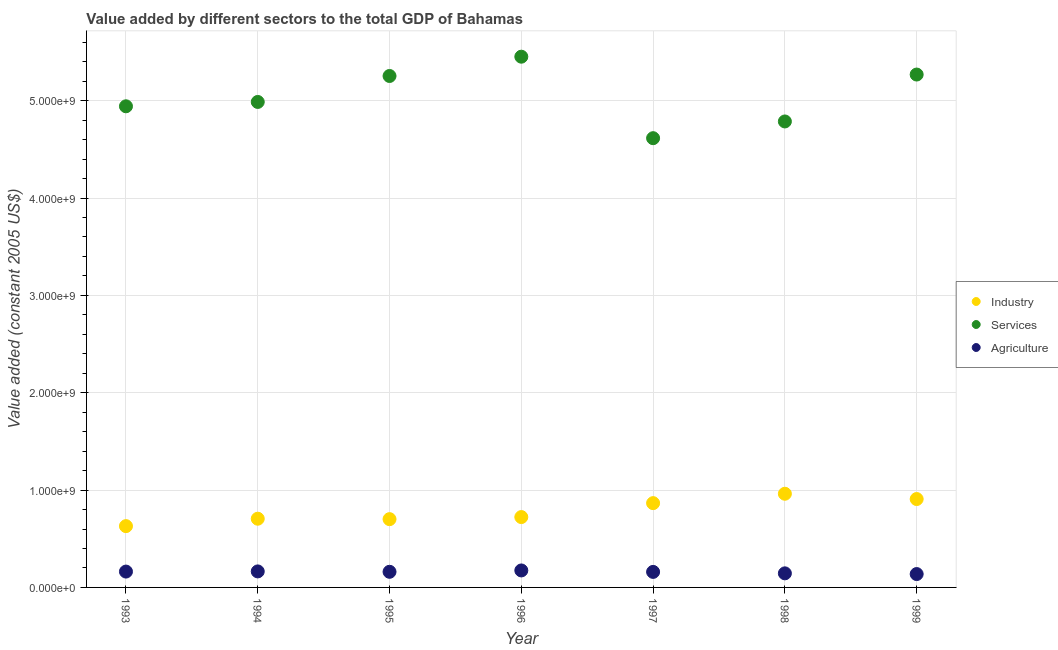Is the number of dotlines equal to the number of legend labels?
Give a very brief answer. Yes. What is the value added by agricultural sector in 1997?
Your answer should be very brief. 1.59e+08. Across all years, what is the maximum value added by agricultural sector?
Your answer should be very brief. 1.74e+08. Across all years, what is the minimum value added by industrial sector?
Offer a very short reply. 6.30e+08. In which year was the value added by services minimum?
Provide a succinct answer. 1997. What is the total value added by industrial sector in the graph?
Your answer should be very brief. 5.50e+09. What is the difference between the value added by services in 1994 and that in 1999?
Offer a terse response. -2.81e+08. What is the difference between the value added by services in 1997 and the value added by agricultural sector in 1995?
Your answer should be compact. 4.45e+09. What is the average value added by industrial sector per year?
Offer a very short reply. 7.85e+08. In the year 1993, what is the difference between the value added by industrial sector and value added by services?
Ensure brevity in your answer.  -4.31e+09. What is the ratio of the value added by industrial sector in 1997 to that in 1999?
Offer a very short reply. 0.95. Is the value added by agricultural sector in 1993 less than that in 1997?
Provide a short and direct response. No. Is the difference between the value added by industrial sector in 1996 and 1997 greater than the difference between the value added by services in 1996 and 1997?
Make the answer very short. No. What is the difference between the highest and the second highest value added by agricultural sector?
Make the answer very short. 9.92e+06. What is the difference between the highest and the lowest value added by industrial sector?
Keep it short and to the point. 3.32e+08. In how many years, is the value added by industrial sector greater than the average value added by industrial sector taken over all years?
Your answer should be compact. 3. Is it the case that in every year, the sum of the value added by industrial sector and value added by services is greater than the value added by agricultural sector?
Provide a succinct answer. Yes. Does the value added by services monotonically increase over the years?
Make the answer very short. No. How many dotlines are there?
Your answer should be very brief. 3. Does the graph contain any zero values?
Keep it short and to the point. No. Where does the legend appear in the graph?
Provide a short and direct response. Center right. What is the title of the graph?
Keep it short and to the point. Value added by different sectors to the total GDP of Bahamas. Does "Ages 15-64" appear as one of the legend labels in the graph?
Your response must be concise. No. What is the label or title of the Y-axis?
Offer a very short reply. Value added (constant 2005 US$). What is the Value added (constant 2005 US$) in Industry in 1993?
Your answer should be compact. 6.30e+08. What is the Value added (constant 2005 US$) in Services in 1993?
Give a very brief answer. 4.94e+09. What is the Value added (constant 2005 US$) in Agriculture in 1993?
Provide a short and direct response. 1.63e+08. What is the Value added (constant 2005 US$) of Industry in 1994?
Provide a succinct answer. 7.06e+08. What is the Value added (constant 2005 US$) in Services in 1994?
Your answer should be compact. 4.99e+09. What is the Value added (constant 2005 US$) in Agriculture in 1994?
Give a very brief answer. 1.65e+08. What is the Value added (constant 2005 US$) in Industry in 1995?
Offer a terse response. 7.01e+08. What is the Value added (constant 2005 US$) in Services in 1995?
Provide a succinct answer. 5.25e+09. What is the Value added (constant 2005 US$) in Agriculture in 1995?
Give a very brief answer. 1.61e+08. What is the Value added (constant 2005 US$) in Industry in 1996?
Offer a very short reply. 7.23e+08. What is the Value added (constant 2005 US$) in Services in 1996?
Offer a very short reply. 5.45e+09. What is the Value added (constant 2005 US$) in Agriculture in 1996?
Your answer should be compact. 1.74e+08. What is the Value added (constant 2005 US$) of Industry in 1997?
Provide a succinct answer. 8.66e+08. What is the Value added (constant 2005 US$) in Services in 1997?
Make the answer very short. 4.61e+09. What is the Value added (constant 2005 US$) of Agriculture in 1997?
Offer a terse response. 1.59e+08. What is the Value added (constant 2005 US$) in Industry in 1998?
Offer a terse response. 9.62e+08. What is the Value added (constant 2005 US$) of Services in 1998?
Provide a succinct answer. 4.79e+09. What is the Value added (constant 2005 US$) of Agriculture in 1998?
Provide a succinct answer. 1.45e+08. What is the Value added (constant 2005 US$) of Industry in 1999?
Your answer should be very brief. 9.08e+08. What is the Value added (constant 2005 US$) of Services in 1999?
Your response must be concise. 5.27e+09. What is the Value added (constant 2005 US$) in Agriculture in 1999?
Provide a short and direct response. 1.37e+08. Across all years, what is the maximum Value added (constant 2005 US$) in Industry?
Offer a very short reply. 9.62e+08. Across all years, what is the maximum Value added (constant 2005 US$) of Services?
Offer a terse response. 5.45e+09. Across all years, what is the maximum Value added (constant 2005 US$) of Agriculture?
Keep it short and to the point. 1.74e+08. Across all years, what is the minimum Value added (constant 2005 US$) of Industry?
Provide a succinct answer. 6.30e+08. Across all years, what is the minimum Value added (constant 2005 US$) of Services?
Your answer should be compact. 4.61e+09. Across all years, what is the minimum Value added (constant 2005 US$) of Agriculture?
Make the answer very short. 1.37e+08. What is the total Value added (constant 2005 US$) of Industry in the graph?
Give a very brief answer. 5.50e+09. What is the total Value added (constant 2005 US$) in Services in the graph?
Your answer should be very brief. 3.53e+1. What is the total Value added (constant 2005 US$) of Agriculture in the graph?
Your response must be concise. 1.10e+09. What is the difference between the Value added (constant 2005 US$) in Industry in 1993 and that in 1994?
Make the answer very short. -7.61e+07. What is the difference between the Value added (constant 2005 US$) of Services in 1993 and that in 1994?
Provide a succinct answer. -4.47e+07. What is the difference between the Value added (constant 2005 US$) of Agriculture in 1993 and that in 1994?
Your response must be concise. -1.69e+06. What is the difference between the Value added (constant 2005 US$) of Industry in 1993 and that in 1995?
Make the answer very short. -7.16e+07. What is the difference between the Value added (constant 2005 US$) in Services in 1993 and that in 1995?
Keep it short and to the point. -3.11e+08. What is the difference between the Value added (constant 2005 US$) in Agriculture in 1993 and that in 1995?
Ensure brevity in your answer.  2.29e+06. What is the difference between the Value added (constant 2005 US$) in Industry in 1993 and that in 1996?
Give a very brief answer. -9.30e+07. What is the difference between the Value added (constant 2005 US$) in Services in 1993 and that in 1996?
Your answer should be compact. -5.10e+08. What is the difference between the Value added (constant 2005 US$) of Agriculture in 1993 and that in 1996?
Make the answer very short. -1.16e+07. What is the difference between the Value added (constant 2005 US$) of Industry in 1993 and that in 1997?
Give a very brief answer. -2.36e+08. What is the difference between the Value added (constant 2005 US$) in Services in 1993 and that in 1997?
Your answer should be compact. 3.28e+08. What is the difference between the Value added (constant 2005 US$) in Agriculture in 1993 and that in 1997?
Make the answer very short. 3.39e+06. What is the difference between the Value added (constant 2005 US$) of Industry in 1993 and that in 1998?
Make the answer very short. -3.32e+08. What is the difference between the Value added (constant 2005 US$) in Services in 1993 and that in 1998?
Ensure brevity in your answer.  1.56e+08. What is the difference between the Value added (constant 2005 US$) of Agriculture in 1993 and that in 1998?
Provide a short and direct response. 1.82e+07. What is the difference between the Value added (constant 2005 US$) of Industry in 1993 and that in 1999?
Your response must be concise. -2.78e+08. What is the difference between the Value added (constant 2005 US$) in Services in 1993 and that in 1999?
Your answer should be compact. -3.26e+08. What is the difference between the Value added (constant 2005 US$) of Agriculture in 1993 and that in 1999?
Provide a succinct answer. 2.55e+07. What is the difference between the Value added (constant 2005 US$) in Industry in 1994 and that in 1995?
Your answer should be very brief. 4.48e+06. What is the difference between the Value added (constant 2005 US$) in Services in 1994 and that in 1995?
Provide a succinct answer. -2.67e+08. What is the difference between the Value added (constant 2005 US$) of Agriculture in 1994 and that in 1995?
Provide a succinct answer. 3.98e+06. What is the difference between the Value added (constant 2005 US$) of Industry in 1994 and that in 1996?
Give a very brief answer. -1.69e+07. What is the difference between the Value added (constant 2005 US$) in Services in 1994 and that in 1996?
Offer a terse response. -4.65e+08. What is the difference between the Value added (constant 2005 US$) of Agriculture in 1994 and that in 1996?
Offer a very short reply. -9.92e+06. What is the difference between the Value added (constant 2005 US$) in Industry in 1994 and that in 1997?
Your answer should be compact. -1.60e+08. What is the difference between the Value added (constant 2005 US$) of Services in 1994 and that in 1997?
Give a very brief answer. 3.72e+08. What is the difference between the Value added (constant 2005 US$) of Agriculture in 1994 and that in 1997?
Your response must be concise. 5.08e+06. What is the difference between the Value added (constant 2005 US$) of Industry in 1994 and that in 1998?
Ensure brevity in your answer.  -2.56e+08. What is the difference between the Value added (constant 2005 US$) of Services in 1994 and that in 1998?
Ensure brevity in your answer.  2.00e+08. What is the difference between the Value added (constant 2005 US$) in Agriculture in 1994 and that in 1998?
Offer a very short reply. 1.99e+07. What is the difference between the Value added (constant 2005 US$) of Industry in 1994 and that in 1999?
Offer a very short reply. -2.02e+08. What is the difference between the Value added (constant 2005 US$) of Services in 1994 and that in 1999?
Your answer should be compact. -2.81e+08. What is the difference between the Value added (constant 2005 US$) in Agriculture in 1994 and that in 1999?
Provide a short and direct response. 2.72e+07. What is the difference between the Value added (constant 2005 US$) of Industry in 1995 and that in 1996?
Provide a succinct answer. -2.14e+07. What is the difference between the Value added (constant 2005 US$) in Services in 1995 and that in 1996?
Offer a very short reply. -1.98e+08. What is the difference between the Value added (constant 2005 US$) in Agriculture in 1995 and that in 1996?
Your response must be concise. -1.39e+07. What is the difference between the Value added (constant 2005 US$) in Industry in 1995 and that in 1997?
Your response must be concise. -1.64e+08. What is the difference between the Value added (constant 2005 US$) in Services in 1995 and that in 1997?
Ensure brevity in your answer.  6.39e+08. What is the difference between the Value added (constant 2005 US$) of Agriculture in 1995 and that in 1997?
Your response must be concise. 1.10e+06. What is the difference between the Value added (constant 2005 US$) in Industry in 1995 and that in 1998?
Offer a very short reply. -2.61e+08. What is the difference between the Value added (constant 2005 US$) of Services in 1995 and that in 1998?
Offer a terse response. 4.67e+08. What is the difference between the Value added (constant 2005 US$) of Agriculture in 1995 and that in 1998?
Give a very brief answer. 1.59e+07. What is the difference between the Value added (constant 2005 US$) of Industry in 1995 and that in 1999?
Provide a succinct answer. -2.07e+08. What is the difference between the Value added (constant 2005 US$) of Services in 1995 and that in 1999?
Your response must be concise. -1.48e+07. What is the difference between the Value added (constant 2005 US$) of Agriculture in 1995 and that in 1999?
Provide a short and direct response. 2.32e+07. What is the difference between the Value added (constant 2005 US$) of Industry in 1996 and that in 1997?
Offer a terse response. -1.43e+08. What is the difference between the Value added (constant 2005 US$) in Services in 1996 and that in 1997?
Ensure brevity in your answer.  8.37e+08. What is the difference between the Value added (constant 2005 US$) of Agriculture in 1996 and that in 1997?
Keep it short and to the point. 1.50e+07. What is the difference between the Value added (constant 2005 US$) in Industry in 1996 and that in 1998?
Your response must be concise. -2.39e+08. What is the difference between the Value added (constant 2005 US$) of Services in 1996 and that in 1998?
Provide a short and direct response. 6.65e+08. What is the difference between the Value added (constant 2005 US$) of Agriculture in 1996 and that in 1998?
Make the answer very short. 2.98e+07. What is the difference between the Value added (constant 2005 US$) of Industry in 1996 and that in 1999?
Make the answer very short. -1.85e+08. What is the difference between the Value added (constant 2005 US$) in Services in 1996 and that in 1999?
Provide a succinct answer. 1.83e+08. What is the difference between the Value added (constant 2005 US$) of Agriculture in 1996 and that in 1999?
Offer a terse response. 3.71e+07. What is the difference between the Value added (constant 2005 US$) of Industry in 1997 and that in 1998?
Your response must be concise. -9.64e+07. What is the difference between the Value added (constant 2005 US$) of Services in 1997 and that in 1998?
Keep it short and to the point. -1.72e+08. What is the difference between the Value added (constant 2005 US$) in Agriculture in 1997 and that in 1998?
Offer a very short reply. 1.48e+07. What is the difference between the Value added (constant 2005 US$) in Industry in 1997 and that in 1999?
Make the answer very short. -4.21e+07. What is the difference between the Value added (constant 2005 US$) of Services in 1997 and that in 1999?
Keep it short and to the point. -6.54e+08. What is the difference between the Value added (constant 2005 US$) of Agriculture in 1997 and that in 1999?
Your answer should be very brief. 2.21e+07. What is the difference between the Value added (constant 2005 US$) in Industry in 1998 and that in 1999?
Offer a very short reply. 5.42e+07. What is the difference between the Value added (constant 2005 US$) of Services in 1998 and that in 1999?
Offer a terse response. -4.82e+08. What is the difference between the Value added (constant 2005 US$) of Agriculture in 1998 and that in 1999?
Your response must be concise. 7.27e+06. What is the difference between the Value added (constant 2005 US$) of Industry in 1993 and the Value added (constant 2005 US$) of Services in 1994?
Offer a very short reply. -4.36e+09. What is the difference between the Value added (constant 2005 US$) in Industry in 1993 and the Value added (constant 2005 US$) in Agriculture in 1994?
Provide a succinct answer. 4.65e+08. What is the difference between the Value added (constant 2005 US$) in Services in 1993 and the Value added (constant 2005 US$) in Agriculture in 1994?
Your answer should be compact. 4.78e+09. What is the difference between the Value added (constant 2005 US$) in Industry in 1993 and the Value added (constant 2005 US$) in Services in 1995?
Your answer should be compact. -4.62e+09. What is the difference between the Value added (constant 2005 US$) in Industry in 1993 and the Value added (constant 2005 US$) in Agriculture in 1995?
Offer a very short reply. 4.69e+08. What is the difference between the Value added (constant 2005 US$) of Services in 1993 and the Value added (constant 2005 US$) of Agriculture in 1995?
Your answer should be very brief. 4.78e+09. What is the difference between the Value added (constant 2005 US$) in Industry in 1993 and the Value added (constant 2005 US$) in Services in 1996?
Offer a terse response. -4.82e+09. What is the difference between the Value added (constant 2005 US$) in Industry in 1993 and the Value added (constant 2005 US$) in Agriculture in 1996?
Make the answer very short. 4.55e+08. What is the difference between the Value added (constant 2005 US$) in Services in 1993 and the Value added (constant 2005 US$) in Agriculture in 1996?
Give a very brief answer. 4.77e+09. What is the difference between the Value added (constant 2005 US$) of Industry in 1993 and the Value added (constant 2005 US$) of Services in 1997?
Give a very brief answer. -3.98e+09. What is the difference between the Value added (constant 2005 US$) of Industry in 1993 and the Value added (constant 2005 US$) of Agriculture in 1997?
Offer a very short reply. 4.70e+08. What is the difference between the Value added (constant 2005 US$) of Services in 1993 and the Value added (constant 2005 US$) of Agriculture in 1997?
Offer a terse response. 4.78e+09. What is the difference between the Value added (constant 2005 US$) of Industry in 1993 and the Value added (constant 2005 US$) of Services in 1998?
Your response must be concise. -4.16e+09. What is the difference between the Value added (constant 2005 US$) of Industry in 1993 and the Value added (constant 2005 US$) of Agriculture in 1998?
Keep it short and to the point. 4.85e+08. What is the difference between the Value added (constant 2005 US$) in Services in 1993 and the Value added (constant 2005 US$) in Agriculture in 1998?
Make the answer very short. 4.80e+09. What is the difference between the Value added (constant 2005 US$) of Industry in 1993 and the Value added (constant 2005 US$) of Services in 1999?
Give a very brief answer. -4.64e+09. What is the difference between the Value added (constant 2005 US$) in Industry in 1993 and the Value added (constant 2005 US$) in Agriculture in 1999?
Keep it short and to the point. 4.92e+08. What is the difference between the Value added (constant 2005 US$) in Services in 1993 and the Value added (constant 2005 US$) in Agriculture in 1999?
Your response must be concise. 4.80e+09. What is the difference between the Value added (constant 2005 US$) of Industry in 1994 and the Value added (constant 2005 US$) of Services in 1995?
Your response must be concise. -4.55e+09. What is the difference between the Value added (constant 2005 US$) in Industry in 1994 and the Value added (constant 2005 US$) in Agriculture in 1995?
Keep it short and to the point. 5.45e+08. What is the difference between the Value added (constant 2005 US$) of Services in 1994 and the Value added (constant 2005 US$) of Agriculture in 1995?
Your response must be concise. 4.83e+09. What is the difference between the Value added (constant 2005 US$) of Industry in 1994 and the Value added (constant 2005 US$) of Services in 1996?
Provide a short and direct response. -4.75e+09. What is the difference between the Value added (constant 2005 US$) in Industry in 1994 and the Value added (constant 2005 US$) in Agriculture in 1996?
Make the answer very short. 5.31e+08. What is the difference between the Value added (constant 2005 US$) of Services in 1994 and the Value added (constant 2005 US$) of Agriculture in 1996?
Give a very brief answer. 4.81e+09. What is the difference between the Value added (constant 2005 US$) in Industry in 1994 and the Value added (constant 2005 US$) in Services in 1997?
Provide a succinct answer. -3.91e+09. What is the difference between the Value added (constant 2005 US$) in Industry in 1994 and the Value added (constant 2005 US$) in Agriculture in 1997?
Your response must be concise. 5.46e+08. What is the difference between the Value added (constant 2005 US$) in Services in 1994 and the Value added (constant 2005 US$) in Agriculture in 1997?
Ensure brevity in your answer.  4.83e+09. What is the difference between the Value added (constant 2005 US$) of Industry in 1994 and the Value added (constant 2005 US$) of Services in 1998?
Make the answer very short. -4.08e+09. What is the difference between the Value added (constant 2005 US$) in Industry in 1994 and the Value added (constant 2005 US$) in Agriculture in 1998?
Your response must be concise. 5.61e+08. What is the difference between the Value added (constant 2005 US$) of Services in 1994 and the Value added (constant 2005 US$) of Agriculture in 1998?
Your response must be concise. 4.84e+09. What is the difference between the Value added (constant 2005 US$) of Industry in 1994 and the Value added (constant 2005 US$) of Services in 1999?
Your answer should be very brief. -4.56e+09. What is the difference between the Value added (constant 2005 US$) in Industry in 1994 and the Value added (constant 2005 US$) in Agriculture in 1999?
Your response must be concise. 5.68e+08. What is the difference between the Value added (constant 2005 US$) of Services in 1994 and the Value added (constant 2005 US$) of Agriculture in 1999?
Your response must be concise. 4.85e+09. What is the difference between the Value added (constant 2005 US$) in Industry in 1995 and the Value added (constant 2005 US$) in Services in 1996?
Make the answer very short. -4.75e+09. What is the difference between the Value added (constant 2005 US$) in Industry in 1995 and the Value added (constant 2005 US$) in Agriculture in 1996?
Give a very brief answer. 5.27e+08. What is the difference between the Value added (constant 2005 US$) of Services in 1995 and the Value added (constant 2005 US$) of Agriculture in 1996?
Provide a succinct answer. 5.08e+09. What is the difference between the Value added (constant 2005 US$) of Industry in 1995 and the Value added (constant 2005 US$) of Services in 1997?
Your answer should be very brief. -3.91e+09. What is the difference between the Value added (constant 2005 US$) in Industry in 1995 and the Value added (constant 2005 US$) in Agriculture in 1997?
Your answer should be compact. 5.42e+08. What is the difference between the Value added (constant 2005 US$) of Services in 1995 and the Value added (constant 2005 US$) of Agriculture in 1997?
Provide a short and direct response. 5.09e+09. What is the difference between the Value added (constant 2005 US$) in Industry in 1995 and the Value added (constant 2005 US$) in Services in 1998?
Provide a short and direct response. -4.09e+09. What is the difference between the Value added (constant 2005 US$) in Industry in 1995 and the Value added (constant 2005 US$) in Agriculture in 1998?
Provide a short and direct response. 5.57e+08. What is the difference between the Value added (constant 2005 US$) of Services in 1995 and the Value added (constant 2005 US$) of Agriculture in 1998?
Provide a succinct answer. 5.11e+09. What is the difference between the Value added (constant 2005 US$) in Industry in 1995 and the Value added (constant 2005 US$) in Services in 1999?
Your answer should be compact. -4.57e+09. What is the difference between the Value added (constant 2005 US$) of Industry in 1995 and the Value added (constant 2005 US$) of Agriculture in 1999?
Offer a terse response. 5.64e+08. What is the difference between the Value added (constant 2005 US$) in Services in 1995 and the Value added (constant 2005 US$) in Agriculture in 1999?
Keep it short and to the point. 5.12e+09. What is the difference between the Value added (constant 2005 US$) in Industry in 1996 and the Value added (constant 2005 US$) in Services in 1997?
Your response must be concise. -3.89e+09. What is the difference between the Value added (constant 2005 US$) of Industry in 1996 and the Value added (constant 2005 US$) of Agriculture in 1997?
Give a very brief answer. 5.63e+08. What is the difference between the Value added (constant 2005 US$) in Services in 1996 and the Value added (constant 2005 US$) in Agriculture in 1997?
Offer a very short reply. 5.29e+09. What is the difference between the Value added (constant 2005 US$) in Industry in 1996 and the Value added (constant 2005 US$) in Services in 1998?
Your answer should be compact. -4.06e+09. What is the difference between the Value added (constant 2005 US$) in Industry in 1996 and the Value added (constant 2005 US$) in Agriculture in 1998?
Make the answer very short. 5.78e+08. What is the difference between the Value added (constant 2005 US$) of Services in 1996 and the Value added (constant 2005 US$) of Agriculture in 1998?
Provide a succinct answer. 5.31e+09. What is the difference between the Value added (constant 2005 US$) of Industry in 1996 and the Value added (constant 2005 US$) of Services in 1999?
Keep it short and to the point. -4.55e+09. What is the difference between the Value added (constant 2005 US$) of Industry in 1996 and the Value added (constant 2005 US$) of Agriculture in 1999?
Offer a terse response. 5.85e+08. What is the difference between the Value added (constant 2005 US$) of Services in 1996 and the Value added (constant 2005 US$) of Agriculture in 1999?
Your answer should be compact. 5.31e+09. What is the difference between the Value added (constant 2005 US$) in Industry in 1997 and the Value added (constant 2005 US$) in Services in 1998?
Offer a terse response. -3.92e+09. What is the difference between the Value added (constant 2005 US$) of Industry in 1997 and the Value added (constant 2005 US$) of Agriculture in 1998?
Keep it short and to the point. 7.21e+08. What is the difference between the Value added (constant 2005 US$) in Services in 1997 and the Value added (constant 2005 US$) in Agriculture in 1998?
Give a very brief answer. 4.47e+09. What is the difference between the Value added (constant 2005 US$) of Industry in 1997 and the Value added (constant 2005 US$) of Services in 1999?
Your answer should be compact. -4.40e+09. What is the difference between the Value added (constant 2005 US$) of Industry in 1997 and the Value added (constant 2005 US$) of Agriculture in 1999?
Your response must be concise. 7.28e+08. What is the difference between the Value added (constant 2005 US$) of Services in 1997 and the Value added (constant 2005 US$) of Agriculture in 1999?
Give a very brief answer. 4.48e+09. What is the difference between the Value added (constant 2005 US$) of Industry in 1998 and the Value added (constant 2005 US$) of Services in 1999?
Keep it short and to the point. -4.31e+09. What is the difference between the Value added (constant 2005 US$) in Industry in 1998 and the Value added (constant 2005 US$) in Agriculture in 1999?
Make the answer very short. 8.25e+08. What is the difference between the Value added (constant 2005 US$) in Services in 1998 and the Value added (constant 2005 US$) in Agriculture in 1999?
Keep it short and to the point. 4.65e+09. What is the average Value added (constant 2005 US$) in Industry per year?
Your response must be concise. 7.85e+08. What is the average Value added (constant 2005 US$) in Services per year?
Provide a succinct answer. 5.04e+09. What is the average Value added (constant 2005 US$) of Agriculture per year?
Ensure brevity in your answer.  1.58e+08. In the year 1993, what is the difference between the Value added (constant 2005 US$) in Industry and Value added (constant 2005 US$) in Services?
Offer a terse response. -4.31e+09. In the year 1993, what is the difference between the Value added (constant 2005 US$) of Industry and Value added (constant 2005 US$) of Agriculture?
Your answer should be very brief. 4.67e+08. In the year 1993, what is the difference between the Value added (constant 2005 US$) in Services and Value added (constant 2005 US$) in Agriculture?
Ensure brevity in your answer.  4.78e+09. In the year 1994, what is the difference between the Value added (constant 2005 US$) of Industry and Value added (constant 2005 US$) of Services?
Your answer should be very brief. -4.28e+09. In the year 1994, what is the difference between the Value added (constant 2005 US$) in Industry and Value added (constant 2005 US$) in Agriculture?
Offer a very short reply. 5.41e+08. In the year 1994, what is the difference between the Value added (constant 2005 US$) of Services and Value added (constant 2005 US$) of Agriculture?
Your answer should be compact. 4.82e+09. In the year 1995, what is the difference between the Value added (constant 2005 US$) of Industry and Value added (constant 2005 US$) of Services?
Give a very brief answer. -4.55e+09. In the year 1995, what is the difference between the Value added (constant 2005 US$) in Industry and Value added (constant 2005 US$) in Agriculture?
Offer a very short reply. 5.41e+08. In the year 1995, what is the difference between the Value added (constant 2005 US$) in Services and Value added (constant 2005 US$) in Agriculture?
Offer a very short reply. 5.09e+09. In the year 1996, what is the difference between the Value added (constant 2005 US$) of Industry and Value added (constant 2005 US$) of Services?
Your answer should be very brief. -4.73e+09. In the year 1996, what is the difference between the Value added (constant 2005 US$) of Industry and Value added (constant 2005 US$) of Agriculture?
Your response must be concise. 5.48e+08. In the year 1996, what is the difference between the Value added (constant 2005 US$) in Services and Value added (constant 2005 US$) in Agriculture?
Make the answer very short. 5.28e+09. In the year 1997, what is the difference between the Value added (constant 2005 US$) of Industry and Value added (constant 2005 US$) of Services?
Provide a short and direct response. -3.75e+09. In the year 1997, what is the difference between the Value added (constant 2005 US$) in Industry and Value added (constant 2005 US$) in Agriculture?
Your answer should be compact. 7.06e+08. In the year 1997, what is the difference between the Value added (constant 2005 US$) in Services and Value added (constant 2005 US$) in Agriculture?
Provide a succinct answer. 4.46e+09. In the year 1998, what is the difference between the Value added (constant 2005 US$) of Industry and Value added (constant 2005 US$) of Services?
Provide a short and direct response. -3.82e+09. In the year 1998, what is the difference between the Value added (constant 2005 US$) in Industry and Value added (constant 2005 US$) in Agriculture?
Offer a very short reply. 8.18e+08. In the year 1998, what is the difference between the Value added (constant 2005 US$) in Services and Value added (constant 2005 US$) in Agriculture?
Your answer should be compact. 4.64e+09. In the year 1999, what is the difference between the Value added (constant 2005 US$) of Industry and Value added (constant 2005 US$) of Services?
Provide a succinct answer. -4.36e+09. In the year 1999, what is the difference between the Value added (constant 2005 US$) in Industry and Value added (constant 2005 US$) in Agriculture?
Your answer should be compact. 7.71e+08. In the year 1999, what is the difference between the Value added (constant 2005 US$) in Services and Value added (constant 2005 US$) in Agriculture?
Provide a short and direct response. 5.13e+09. What is the ratio of the Value added (constant 2005 US$) of Industry in 1993 to that in 1994?
Keep it short and to the point. 0.89. What is the ratio of the Value added (constant 2005 US$) of Industry in 1993 to that in 1995?
Your answer should be very brief. 0.9. What is the ratio of the Value added (constant 2005 US$) in Services in 1993 to that in 1995?
Your response must be concise. 0.94. What is the ratio of the Value added (constant 2005 US$) of Agriculture in 1993 to that in 1995?
Provide a succinct answer. 1.01. What is the ratio of the Value added (constant 2005 US$) of Industry in 1993 to that in 1996?
Ensure brevity in your answer.  0.87. What is the ratio of the Value added (constant 2005 US$) of Services in 1993 to that in 1996?
Keep it short and to the point. 0.91. What is the ratio of the Value added (constant 2005 US$) of Agriculture in 1993 to that in 1996?
Offer a very short reply. 0.93. What is the ratio of the Value added (constant 2005 US$) of Industry in 1993 to that in 1997?
Make the answer very short. 0.73. What is the ratio of the Value added (constant 2005 US$) of Services in 1993 to that in 1997?
Your answer should be very brief. 1.07. What is the ratio of the Value added (constant 2005 US$) of Agriculture in 1993 to that in 1997?
Provide a succinct answer. 1.02. What is the ratio of the Value added (constant 2005 US$) of Industry in 1993 to that in 1998?
Keep it short and to the point. 0.65. What is the ratio of the Value added (constant 2005 US$) of Services in 1993 to that in 1998?
Your answer should be very brief. 1.03. What is the ratio of the Value added (constant 2005 US$) in Agriculture in 1993 to that in 1998?
Your response must be concise. 1.13. What is the ratio of the Value added (constant 2005 US$) in Industry in 1993 to that in 1999?
Provide a succinct answer. 0.69. What is the ratio of the Value added (constant 2005 US$) in Services in 1993 to that in 1999?
Ensure brevity in your answer.  0.94. What is the ratio of the Value added (constant 2005 US$) of Agriculture in 1993 to that in 1999?
Ensure brevity in your answer.  1.19. What is the ratio of the Value added (constant 2005 US$) of Industry in 1994 to that in 1995?
Provide a succinct answer. 1.01. What is the ratio of the Value added (constant 2005 US$) in Services in 1994 to that in 1995?
Ensure brevity in your answer.  0.95. What is the ratio of the Value added (constant 2005 US$) in Agriculture in 1994 to that in 1995?
Ensure brevity in your answer.  1.02. What is the ratio of the Value added (constant 2005 US$) in Industry in 1994 to that in 1996?
Provide a short and direct response. 0.98. What is the ratio of the Value added (constant 2005 US$) in Services in 1994 to that in 1996?
Provide a short and direct response. 0.91. What is the ratio of the Value added (constant 2005 US$) of Agriculture in 1994 to that in 1996?
Offer a terse response. 0.94. What is the ratio of the Value added (constant 2005 US$) of Industry in 1994 to that in 1997?
Provide a succinct answer. 0.82. What is the ratio of the Value added (constant 2005 US$) in Services in 1994 to that in 1997?
Ensure brevity in your answer.  1.08. What is the ratio of the Value added (constant 2005 US$) of Agriculture in 1994 to that in 1997?
Keep it short and to the point. 1.03. What is the ratio of the Value added (constant 2005 US$) in Industry in 1994 to that in 1998?
Your answer should be very brief. 0.73. What is the ratio of the Value added (constant 2005 US$) of Services in 1994 to that in 1998?
Offer a very short reply. 1.04. What is the ratio of the Value added (constant 2005 US$) in Agriculture in 1994 to that in 1998?
Ensure brevity in your answer.  1.14. What is the ratio of the Value added (constant 2005 US$) of Industry in 1994 to that in 1999?
Provide a succinct answer. 0.78. What is the ratio of the Value added (constant 2005 US$) of Services in 1994 to that in 1999?
Your answer should be compact. 0.95. What is the ratio of the Value added (constant 2005 US$) of Agriculture in 1994 to that in 1999?
Your answer should be compact. 1.2. What is the ratio of the Value added (constant 2005 US$) of Industry in 1995 to that in 1996?
Your answer should be very brief. 0.97. What is the ratio of the Value added (constant 2005 US$) of Services in 1995 to that in 1996?
Provide a succinct answer. 0.96. What is the ratio of the Value added (constant 2005 US$) of Agriculture in 1995 to that in 1996?
Offer a terse response. 0.92. What is the ratio of the Value added (constant 2005 US$) in Industry in 1995 to that in 1997?
Your answer should be compact. 0.81. What is the ratio of the Value added (constant 2005 US$) of Services in 1995 to that in 1997?
Your response must be concise. 1.14. What is the ratio of the Value added (constant 2005 US$) in Industry in 1995 to that in 1998?
Your answer should be compact. 0.73. What is the ratio of the Value added (constant 2005 US$) of Services in 1995 to that in 1998?
Your response must be concise. 1.1. What is the ratio of the Value added (constant 2005 US$) in Agriculture in 1995 to that in 1998?
Offer a very short reply. 1.11. What is the ratio of the Value added (constant 2005 US$) in Industry in 1995 to that in 1999?
Your response must be concise. 0.77. What is the ratio of the Value added (constant 2005 US$) of Services in 1995 to that in 1999?
Your response must be concise. 1. What is the ratio of the Value added (constant 2005 US$) of Agriculture in 1995 to that in 1999?
Your response must be concise. 1.17. What is the ratio of the Value added (constant 2005 US$) of Industry in 1996 to that in 1997?
Make the answer very short. 0.83. What is the ratio of the Value added (constant 2005 US$) of Services in 1996 to that in 1997?
Give a very brief answer. 1.18. What is the ratio of the Value added (constant 2005 US$) of Agriculture in 1996 to that in 1997?
Make the answer very short. 1.09. What is the ratio of the Value added (constant 2005 US$) of Industry in 1996 to that in 1998?
Provide a succinct answer. 0.75. What is the ratio of the Value added (constant 2005 US$) in Services in 1996 to that in 1998?
Offer a terse response. 1.14. What is the ratio of the Value added (constant 2005 US$) of Agriculture in 1996 to that in 1998?
Give a very brief answer. 1.21. What is the ratio of the Value added (constant 2005 US$) in Industry in 1996 to that in 1999?
Ensure brevity in your answer.  0.8. What is the ratio of the Value added (constant 2005 US$) in Services in 1996 to that in 1999?
Your answer should be very brief. 1.03. What is the ratio of the Value added (constant 2005 US$) of Agriculture in 1996 to that in 1999?
Keep it short and to the point. 1.27. What is the ratio of the Value added (constant 2005 US$) in Industry in 1997 to that in 1998?
Keep it short and to the point. 0.9. What is the ratio of the Value added (constant 2005 US$) in Services in 1997 to that in 1998?
Make the answer very short. 0.96. What is the ratio of the Value added (constant 2005 US$) in Agriculture in 1997 to that in 1998?
Keep it short and to the point. 1.1. What is the ratio of the Value added (constant 2005 US$) in Industry in 1997 to that in 1999?
Provide a succinct answer. 0.95. What is the ratio of the Value added (constant 2005 US$) of Services in 1997 to that in 1999?
Your answer should be compact. 0.88. What is the ratio of the Value added (constant 2005 US$) of Agriculture in 1997 to that in 1999?
Your response must be concise. 1.16. What is the ratio of the Value added (constant 2005 US$) of Industry in 1998 to that in 1999?
Provide a succinct answer. 1.06. What is the ratio of the Value added (constant 2005 US$) of Services in 1998 to that in 1999?
Your answer should be compact. 0.91. What is the ratio of the Value added (constant 2005 US$) of Agriculture in 1998 to that in 1999?
Give a very brief answer. 1.05. What is the difference between the highest and the second highest Value added (constant 2005 US$) of Industry?
Offer a very short reply. 5.42e+07. What is the difference between the highest and the second highest Value added (constant 2005 US$) in Services?
Ensure brevity in your answer.  1.83e+08. What is the difference between the highest and the second highest Value added (constant 2005 US$) of Agriculture?
Offer a terse response. 9.92e+06. What is the difference between the highest and the lowest Value added (constant 2005 US$) in Industry?
Make the answer very short. 3.32e+08. What is the difference between the highest and the lowest Value added (constant 2005 US$) in Services?
Offer a terse response. 8.37e+08. What is the difference between the highest and the lowest Value added (constant 2005 US$) of Agriculture?
Ensure brevity in your answer.  3.71e+07. 